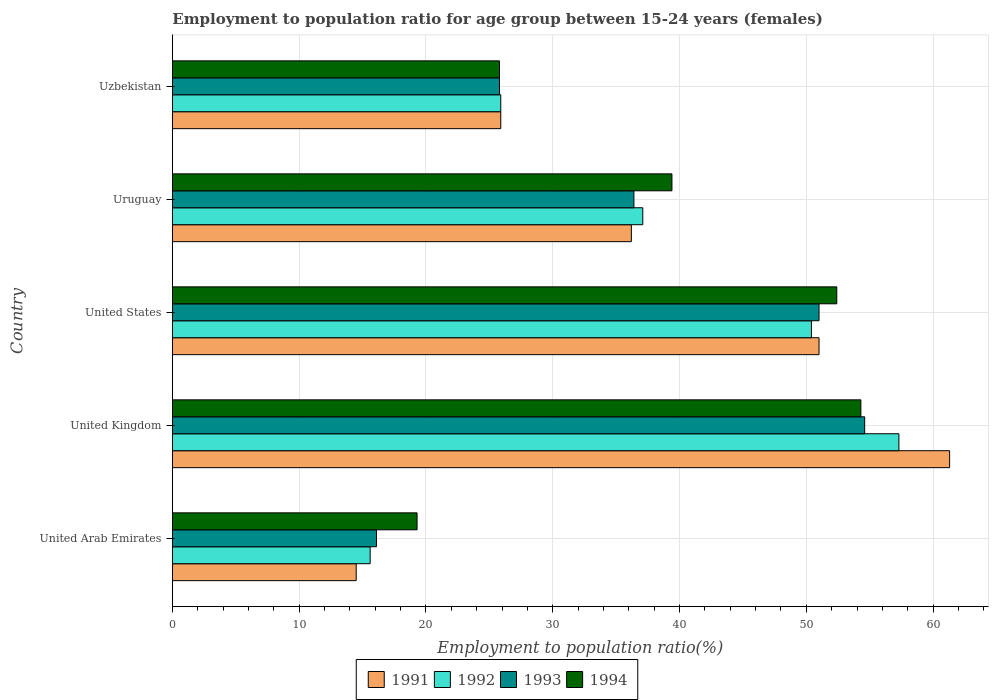How many groups of bars are there?
Ensure brevity in your answer.  5. How many bars are there on the 5th tick from the bottom?
Your response must be concise. 4. What is the label of the 5th group of bars from the top?
Make the answer very short. United Arab Emirates. What is the employment to population ratio in 1992 in United Kingdom?
Ensure brevity in your answer.  57.3. Across all countries, what is the maximum employment to population ratio in 1991?
Your answer should be compact. 61.3. Across all countries, what is the minimum employment to population ratio in 1993?
Keep it short and to the point. 16.1. In which country was the employment to population ratio in 1992 minimum?
Offer a terse response. United Arab Emirates. What is the total employment to population ratio in 1992 in the graph?
Your answer should be very brief. 186.3. What is the difference between the employment to population ratio in 1991 in Uruguay and that in Uzbekistan?
Give a very brief answer. 10.3. What is the difference between the employment to population ratio in 1992 in United Kingdom and the employment to population ratio in 1994 in United Arab Emirates?
Your answer should be very brief. 38. What is the average employment to population ratio in 1992 per country?
Your answer should be compact. 37.26. What is the difference between the employment to population ratio in 1991 and employment to population ratio in 1992 in Uruguay?
Provide a succinct answer. -0.9. What is the ratio of the employment to population ratio in 1993 in United Arab Emirates to that in United States?
Provide a succinct answer. 0.32. Is the employment to population ratio in 1994 in United Arab Emirates less than that in Uruguay?
Give a very brief answer. Yes. Is the difference between the employment to population ratio in 1991 in United Arab Emirates and Uzbekistan greater than the difference between the employment to population ratio in 1992 in United Arab Emirates and Uzbekistan?
Your answer should be compact. No. What is the difference between the highest and the second highest employment to population ratio in 1992?
Give a very brief answer. 6.9. What is the difference between the highest and the lowest employment to population ratio in 1992?
Offer a terse response. 41.7. Is it the case that in every country, the sum of the employment to population ratio in 1993 and employment to population ratio in 1992 is greater than the sum of employment to population ratio in 1994 and employment to population ratio in 1991?
Offer a terse response. No. Are all the bars in the graph horizontal?
Make the answer very short. Yes. How many countries are there in the graph?
Offer a very short reply. 5. What is the difference between two consecutive major ticks on the X-axis?
Your response must be concise. 10. Are the values on the major ticks of X-axis written in scientific E-notation?
Provide a succinct answer. No. Does the graph contain any zero values?
Your response must be concise. No. Where does the legend appear in the graph?
Your answer should be compact. Bottom center. How many legend labels are there?
Make the answer very short. 4. What is the title of the graph?
Your answer should be compact. Employment to population ratio for age group between 15-24 years (females). Does "1990" appear as one of the legend labels in the graph?
Give a very brief answer. No. What is the label or title of the X-axis?
Provide a succinct answer. Employment to population ratio(%). What is the label or title of the Y-axis?
Ensure brevity in your answer.  Country. What is the Employment to population ratio(%) of 1991 in United Arab Emirates?
Your response must be concise. 14.5. What is the Employment to population ratio(%) in 1992 in United Arab Emirates?
Offer a very short reply. 15.6. What is the Employment to population ratio(%) of 1993 in United Arab Emirates?
Make the answer very short. 16.1. What is the Employment to population ratio(%) in 1994 in United Arab Emirates?
Your answer should be compact. 19.3. What is the Employment to population ratio(%) in 1991 in United Kingdom?
Keep it short and to the point. 61.3. What is the Employment to population ratio(%) in 1992 in United Kingdom?
Your answer should be compact. 57.3. What is the Employment to population ratio(%) in 1993 in United Kingdom?
Offer a terse response. 54.6. What is the Employment to population ratio(%) in 1994 in United Kingdom?
Provide a short and direct response. 54.3. What is the Employment to population ratio(%) of 1991 in United States?
Your answer should be compact. 51. What is the Employment to population ratio(%) in 1992 in United States?
Offer a terse response. 50.4. What is the Employment to population ratio(%) in 1993 in United States?
Make the answer very short. 51. What is the Employment to population ratio(%) in 1994 in United States?
Offer a very short reply. 52.4. What is the Employment to population ratio(%) in 1991 in Uruguay?
Provide a succinct answer. 36.2. What is the Employment to population ratio(%) of 1992 in Uruguay?
Ensure brevity in your answer.  37.1. What is the Employment to population ratio(%) in 1993 in Uruguay?
Provide a succinct answer. 36.4. What is the Employment to population ratio(%) of 1994 in Uruguay?
Make the answer very short. 39.4. What is the Employment to population ratio(%) of 1991 in Uzbekistan?
Make the answer very short. 25.9. What is the Employment to population ratio(%) in 1992 in Uzbekistan?
Make the answer very short. 25.9. What is the Employment to population ratio(%) of 1993 in Uzbekistan?
Your response must be concise. 25.8. What is the Employment to population ratio(%) of 1994 in Uzbekistan?
Give a very brief answer. 25.8. Across all countries, what is the maximum Employment to population ratio(%) of 1991?
Offer a very short reply. 61.3. Across all countries, what is the maximum Employment to population ratio(%) of 1992?
Your response must be concise. 57.3. Across all countries, what is the maximum Employment to population ratio(%) of 1993?
Your answer should be compact. 54.6. Across all countries, what is the maximum Employment to population ratio(%) in 1994?
Ensure brevity in your answer.  54.3. Across all countries, what is the minimum Employment to population ratio(%) in 1991?
Ensure brevity in your answer.  14.5. Across all countries, what is the minimum Employment to population ratio(%) in 1992?
Provide a short and direct response. 15.6. Across all countries, what is the minimum Employment to population ratio(%) in 1993?
Provide a short and direct response. 16.1. Across all countries, what is the minimum Employment to population ratio(%) in 1994?
Make the answer very short. 19.3. What is the total Employment to population ratio(%) in 1991 in the graph?
Provide a succinct answer. 188.9. What is the total Employment to population ratio(%) of 1992 in the graph?
Offer a very short reply. 186.3. What is the total Employment to population ratio(%) in 1993 in the graph?
Provide a succinct answer. 183.9. What is the total Employment to population ratio(%) in 1994 in the graph?
Provide a succinct answer. 191.2. What is the difference between the Employment to population ratio(%) in 1991 in United Arab Emirates and that in United Kingdom?
Give a very brief answer. -46.8. What is the difference between the Employment to population ratio(%) in 1992 in United Arab Emirates and that in United Kingdom?
Give a very brief answer. -41.7. What is the difference between the Employment to population ratio(%) of 1993 in United Arab Emirates and that in United Kingdom?
Keep it short and to the point. -38.5. What is the difference between the Employment to population ratio(%) of 1994 in United Arab Emirates and that in United Kingdom?
Offer a very short reply. -35. What is the difference between the Employment to population ratio(%) in 1991 in United Arab Emirates and that in United States?
Ensure brevity in your answer.  -36.5. What is the difference between the Employment to population ratio(%) in 1992 in United Arab Emirates and that in United States?
Make the answer very short. -34.8. What is the difference between the Employment to population ratio(%) of 1993 in United Arab Emirates and that in United States?
Keep it short and to the point. -34.9. What is the difference between the Employment to population ratio(%) in 1994 in United Arab Emirates and that in United States?
Provide a succinct answer. -33.1. What is the difference between the Employment to population ratio(%) of 1991 in United Arab Emirates and that in Uruguay?
Keep it short and to the point. -21.7. What is the difference between the Employment to population ratio(%) of 1992 in United Arab Emirates and that in Uruguay?
Make the answer very short. -21.5. What is the difference between the Employment to population ratio(%) in 1993 in United Arab Emirates and that in Uruguay?
Offer a very short reply. -20.3. What is the difference between the Employment to population ratio(%) in 1994 in United Arab Emirates and that in Uruguay?
Ensure brevity in your answer.  -20.1. What is the difference between the Employment to population ratio(%) of 1992 in United Arab Emirates and that in Uzbekistan?
Offer a very short reply. -10.3. What is the difference between the Employment to population ratio(%) in 1993 in United Arab Emirates and that in Uzbekistan?
Offer a very short reply. -9.7. What is the difference between the Employment to population ratio(%) in 1991 in United Kingdom and that in United States?
Provide a short and direct response. 10.3. What is the difference between the Employment to population ratio(%) in 1992 in United Kingdom and that in United States?
Provide a succinct answer. 6.9. What is the difference between the Employment to population ratio(%) of 1993 in United Kingdom and that in United States?
Provide a short and direct response. 3.6. What is the difference between the Employment to population ratio(%) of 1994 in United Kingdom and that in United States?
Offer a very short reply. 1.9. What is the difference between the Employment to population ratio(%) in 1991 in United Kingdom and that in Uruguay?
Offer a very short reply. 25.1. What is the difference between the Employment to population ratio(%) of 1992 in United Kingdom and that in Uruguay?
Your answer should be compact. 20.2. What is the difference between the Employment to population ratio(%) in 1994 in United Kingdom and that in Uruguay?
Keep it short and to the point. 14.9. What is the difference between the Employment to population ratio(%) in 1991 in United Kingdom and that in Uzbekistan?
Provide a succinct answer. 35.4. What is the difference between the Employment to population ratio(%) of 1992 in United Kingdom and that in Uzbekistan?
Provide a short and direct response. 31.4. What is the difference between the Employment to population ratio(%) in 1993 in United Kingdom and that in Uzbekistan?
Make the answer very short. 28.8. What is the difference between the Employment to population ratio(%) in 1992 in United States and that in Uruguay?
Offer a very short reply. 13.3. What is the difference between the Employment to population ratio(%) in 1994 in United States and that in Uruguay?
Offer a very short reply. 13. What is the difference between the Employment to population ratio(%) of 1991 in United States and that in Uzbekistan?
Offer a terse response. 25.1. What is the difference between the Employment to population ratio(%) of 1992 in United States and that in Uzbekistan?
Give a very brief answer. 24.5. What is the difference between the Employment to population ratio(%) of 1993 in United States and that in Uzbekistan?
Your answer should be very brief. 25.2. What is the difference between the Employment to population ratio(%) in 1994 in United States and that in Uzbekistan?
Your answer should be very brief. 26.6. What is the difference between the Employment to population ratio(%) in 1991 in Uruguay and that in Uzbekistan?
Offer a terse response. 10.3. What is the difference between the Employment to population ratio(%) of 1993 in Uruguay and that in Uzbekistan?
Give a very brief answer. 10.6. What is the difference between the Employment to population ratio(%) in 1994 in Uruguay and that in Uzbekistan?
Your response must be concise. 13.6. What is the difference between the Employment to population ratio(%) of 1991 in United Arab Emirates and the Employment to population ratio(%) of 1992 in United Kingdom?
Give a very brief answer. -42.8. What is the difference between the Employment to population ratio(%) in 1991 in United Arab Emirates and the Employment to population ratio(%) in 1993 in United Kingdom?
Your answer should be very brief. -40.1. What is the difference between the Employment to population ratio(%) of 1991 in United Arab Emirates and the Employment to population ratio(%) of 1994 in United Kingdom?
Provide a succinct answer. -39.8. What is the difference between the Employment to population ratio(%) of 1992 in United Arab Emirates and the Employment to population ratio(%) of 1993 in United Kingdom?
Keep it short and to the point. -39. What is the difference between the Employment to population ratio(%) of 1992 in United Arab Emirates and the Employment to population ratio(%) of 1994 in United Kingdom?
Make the answer very short. -38.7. What is the difference between the Employment to population ratio(%) of 1993 in United Arab Emirates and the Employment to population ratio(%) of 1994 in United Kingdom?
Ensure brevity in your answer.  -38.2. What is the difference between the Employment to population ratio(%) of 1991 in United Arab Emirates and the Employment to population ratio(%) of 1992 in United States?
Provide a short and direct response. -35.9. What is the difference between the Employment to population ratio(%) in 1991 in United Arab Emirates and the Employment to population ratio(%) in 1993 in United States?
Your answer should be very brief. -36.5. What is the difference between the Employment to population ratio(%) of 1991 in United Arab Emirates and the Employment to population ratio(%) of 1994 in United States?
Offer a very short reply. -37.9. What is the difference between the Employment to population ratio(%) of 1992 in United Arab Emirates and the Employment to population ratio(%) of 1993 in United States?
Your answer should be compact. -35.4. What is the difference between the Employment to population ratio(%) of 1992 in United Arab Emirates and the Employment to population ratio(%) of 1994 in United States?
Make the answer very short. -36.8. What is the difference between the Employment to population ratio(%) of 1993 in United Arab Emirates and the Employment to population ratio(%) of 1994 in United States?
Ensure brevity in your answer.  -36.3. What is the difference between the Employment to population ratio(%) of 1991 in United Arab Emirates and the Employment to population ratio(%) of 1992 in Uruguay?
Offer a terse response. -22.6. What is the difference between the Employment to population ratio(%) in 1991 in United Arab Emirates and the Employment to population ratio(%) in 1993 in Uruguay?
Your response must be concise. -21.9. What is the difference between the Employment to population ratio(%) in 1991 in United Arab Emirates and the Employment to population ratio(%) in 1994 in Uruguay?
Provide a short and direct response. -24.9. What is the difference between the Employment to population ratio(%) in 1992 in United Arab Emirates and the Employment to population ratio(%) in 1993 in Uruguay?
Keep it short and to the point. -20.8. What is the difference between the Employment to population ratio(%) of 1992 in United Arab Emirates and the Employment to population ratio(%) of 1994 in Uruguay?
Keep it short and to the point. -23.8. What is the difference between the Employment to population ratio(%) in 1993 in United Arab Emirates and the Employment to population ratio(%) in 1994 in Uruguay?
Ensure brevity in your answer.  -23.3. What is the difference between the Employment to population ratio(%) in 1991 in United Arab Emirates and the Employment to population ratio(%) in 1994 in Uzbekistan?
Make the answer very short. -11.3. What is the difference between the Employment to population ratio(%) in 1991 in United Kingdom and the Employment to population ratio(%) in 1992 in United States?
Give a very brief answer. 10.9. What is the difference between the Employment to population ratio(%) of 1992 in United Kingdom and the Employment to population ratio(%) of 1993 in United States?
Provide a succinct answer. 6.3. What is the difference between the Employment to population ratio(%) of 1992 in United Kingdom and the Employment to population ratio(%) of 1994 in United States?
Provide a succinct answer. 4.9. What is the difference between the Employment to population ratio(%) in 1991 in United Kingdom and the Employment to population ratio(%) in 1992 in Uruguay?
Provide a short and direct response. 24.2. What is the difference between the Employment to population ratio(%) in 1991 in United Kingdom and the Employment to population ratio(%) in 1993 in Uruguay?
Your response must be concise. 24.9. What is the difference between the Employment to population ratio(%) of 1991 in United Kingdom and the Employment to population ratio(%) of 1994 in Uruguay?
Your answer should be very brief. 21.9. What is the difference between the Employment to population ratio(%) in 1992 in United Kingdom and the Employment to population ratio(%) in 1993 in Uruguay?
Provide a succinct answer. 20.9. What is the difference between the Employment to population ratio(%) of 1991 in United Kingdom and the Employment to population ratio(%) of 1992 in Uzbekistan?
Offer a terse response. 35.4. What is the difference between the Employment to population ratio(%) of 1991 in United Kingdom and the Employment to population ratio(%) of 1993 in Uzbekistan?
Your answer should be very brief. 35.5. What is the difference between the Employment to population ratio(%) in 1991 in United Kingdom and the Employment to population ratio(%) in 1994 in Uzbekistan?
Your response must be concise. 35.5. What is the difference between the Employment to population ratio(%) of 1992 in United Kingdom and the Employment to population ratio(%) of 1993 in Uzbekistan?
Give a very brief answer. 31.5. What is the difference between the Employment to population ratio(%) in 1992 in United Kingdom and the Employment to population ratio(%) in 1994 in Uzbekistan?
Your answer should be compact. 31.5. What is the difference between the Employment to population ratio(%) in 1993 in United Kingdom and the Employment to population ratio(%) in 1994 in Uzbekistan?
Give a very brief answer. 28.8. What is the difference between the Employment to population ratio(%) in 1991 in United States and the Employment to population ratio(%) in 1992 in Uruguay?
Ensure brevity in your answer.  13.9. What is the difference between the Employment to population ratio(%) in 1991 in United States and the Employment to population ratio(%) in 1993 in Uruguay?
Offer a terse response. 14.6. What is the difference between the Employment to population ratio(%) in 1991 in United States and the Employment to population ratio(%) in 1994 in Uruguay?
Your response must be concise. 11.6. What is the difference between the Employment to population ratio(%) of 1992 in United States and the Employment to population ratio(%) of 1994 in Uruguay?
Offer a terse response. 11. What is the difference between the Employment to population ratio(%) in 1993 in United States and the Employment to population ratio(%) in 1994 in Uruguay?
Give a very brief answer. 11.6. What is the difference between the Employment to population ratio(%) in 1991 in United States and the Employment to population ratio(%) in 1992 in Uzbekistan?
Ensure brevity in your answer.  25.1. What is the difference between the Employment to population ratio(%) in 1991 in United States and the Employment to population ratio(%) in 1993 in Uzbekistan?
Ensure brevity in your answer.  25.2. What is the difference between the Employment to population ratio(%) of 1991 in United States and the Employment to population ratio(%) of 1994 in Uzbekistan?
Make the answer very short. 25.2. What is the difference between the Employment to population ratio(%) of 1992 in United States and the Employment to population ratio(%) of 1993 in Uzbekistan?
Your answer should be very brief. 24.6. What is the difference between the Employment to population ratio(%) of 1992 in United States and the Employment to population ratio(%) of 1994 in Uzbekistan?
Your answer should be compact. 24.6. What is the difference between the Employment to population ratio(%) of 1993 in United States and the Employment to population ratio(%) of 1994 in Uzbekistan?
Make the answer very short. 25.2. What is the difference between the Employment to population ratio(%) of 1991 in Uruguay and the Employment to population ratio(%) of 1993 in Uzbekistan?
Your answer should be very brief. 10.4. What is the difference between the Employment to population ratio(%) in 1992 in Uruguay and the Employment to population ratio(%) in 1993 in Uzbekistan?
Offer a terse response. 11.3. What is the difference between the Employment to population ratio(%) of 1992 in Uruguay and the Employment to population ratio(%) of 1994 in Uzbekistan?
Your answer should be compact. 11.3. What is the average Employment to population ratio(%) of 1991 per country?
Your answer should be very brief. 37.78. What is the average Employment to population ratio(%) of 1992 per country?
Provide a short and direct response. 37.26. What is the average Employment to population ratio(%) in 1993 per country?
Offer a terse response. 36.78. What is the average Employment to population ratio(%) in 1994 per country?
Give a very brief answer. 38.24. What is the difference between the Employment to population ratio(%) of 1991 and Employment to population ratio(%) of 1992 in United Arab Emirates?
Ensure brevity in your answer.  -1.1. What is the difference between the Employment to population ratio(%) of 1991 and Employment to population ratio(%) of 1994 in United Arab Emirates?
Give a very brief answer. -4.8. What is the difference between the Employment to population ratio(%) in 1992 and Employment to population ratio(%) in 1993 in United Arab Emirates?
Offer a very short reply. -0.5. What is the difference between the Employment to population ratio(%) of 1992 and Employment to population ratio(%) of 1994 in United Arab Emirates?
Your answer should be compact. -3.7. What is the difference between the Employment to population ratio(%) in 1993 and Employment to population ratio(%) in 1994 in United Arab Emirates?
Give a very brief answer. -3.2. What is the difference between the Employment to population ratio(%) of 1991 and Employment to population ratio(%) of 1994 in United Kingdom?
Your answer should be compact. 7. What is the difference between the Employment to population ratio(%) in 1992 and Employment to population ratio(%) in 1993 in United Kingdom?
Offer a very short reply. 2.7. What is the difference between the Employment to population ratio(%) in 1991 and Employment to population ratio(%) in 1993 in United States?
Give a very brief answer. 0. What is the difference between the Employment to population ratio(%) in 1993 and Employment to population ratio(%) in 1994 in United States?
Provide a short and direct response. -1.4. What is the difference between the Employment to population ratio(%) in 1991 and Employment to population ratio(%) in 1994 in Uruguay?
Provide a succinct answer. -3.2. What is the difference between the Employment to population ratio(%) of 1991 and Employment to population ratio(%) of 1992 in Uzbekistan?
Offer a terse response. 0. What is the difference between the Employment to population ratio(%) of 1991 and Employment to population ratio(%) of 1994 in Uzbekistan?
Ensure brevity in your answer.  0.1. What is the difference between the Employment to population ratio(%) of 1992 and Employment to population ratio(%) of 1994 in Uzbekistan?
Offer a very short reply. 0.1. What is the difference between the Employment to population ratio(%) in 1993 and Employment to population ratio(%) in 1994 in Uzbekistan?
Offer a very short reply. 0. What is the ratio of the Employment to population ratio(%) of 1991 in United Arab Emirates to that in United Kingdom?
Give a very brief answer. 0.24. What is the ratio of the Employment to population ratio(%) in 1992 in United Arab Emirates to that in United Kingdom?
Your answer should be very brief. 0.27. What is the ratio of the Employment to population ratio(%) in 1993 in United Arab Emirates to that in United Kingdom?
Give a very brief answer. 0.29. What is the ratio of the Employment to population ratio(%) in 1994 in United Arab Emirates to that in United Kingdom?
Ensure brevity in your answer.  0.36. What is the ratio of the Employment to population ratio(%) of 1991 in United Arab Emirates to that in United States?
Your response must be concise. 0.28. What is the ratio of the Employment to population ratio(%) in 1992 in United Arab Emirates to that in United States?
Make the answer very short. 0.31. What is the ratio of the Employment to population ratio(%) in 1993 in United Arab Emirates to that in United States?
Give a very brief answer. 0.32. What is the ratio of the Employment to population ratio(%) of 1994 in United Arab Emirates to that in United States?
Offer a very short reply. 0.37. What is the ratio of the Employment to population ratio(%) of 1991 in United Arab Emirates to that in Uruguay?
Ensure brevity in your answer.  0.4. What is the ratio of the Employment to population ratio(%) in 1992 in United Arab Emirates to that in Uruguay?
Your answer should be compact. 0.42. What is the ratio of the Employment to population ratio(%) in 1993 in United Arab Emirates to that in Uruguay?
Keep it short and to the point. 0.44. What is the ratio of the Employment to population ratio(%) in 1994 in United Arab Emirates to that in Uruguay?
Provide a short and direct response. 0.49. What is the ratio of the Employment to population ratio(%) in 1991 in United Arab Emirates to that in Uzbekistan?
Ensure brevity in your answer.  0.56. What is the ratio of the Employment to population ratio(%) of 1992 in United Arab Emirates to that in Uzbekistan?
Your response must be concise. 0.6. What is the ratio of the Employment to population ratio(%) in 1993 in United Arab Emirates to that in Uzbekistan?
Provide a succinct answer. 0.62. What is the ratio of the Employment to population ratio(%) of 1994 in United Arab Emirates to that in Uzbekistan?
Make the answer very short. 0.75. What is the ratio of the Employment to population ratio(%) of 1991 in United Kingdom to that in United States?
Make the answer very short. 1.2. What is the ratio of the Employment to population ratio(%) of 1992 in United Kingdom to that in United States?
Provide a succinct answer. 1.14. What is the ratio of the Employment to population ratio(%) of 1993 in United Kingdom to that in United States?
Keep it short and to the point. 1.07. What is the ratio of the Employment to population ratio(%) in 1994 in United Kingdom to that in United States?
Provide a succinct answer. 1.04. What is the ratio of the Employment to population ratio(%) in 1991 in United Kingdom to that in Uruguay?
Give a very brief answer. 1.69. What is the ratio of the Employment to population ratio(%) in 1992 in United Kingdom to that in Uruguay?
Your answer should be very brief. 1.54. What is the ratio of the Employment to population ratio(%) of 1993 in United Kingdom to that in Uruguay?
Your response must be concise. 1.5. What is the ratio of the Employment to population ratio(%) in 1994 in United Kingdom to that in Uruguay?
Your answer should be compact. 1.38. What is the ratio of the Employment to population ratio(%) of 1991 in United Kingdom to that in Uzbekistan?
Your answer should be very brief. 2.37. What is the ratio of the Employment to population ratio(%) in 1992 in United Kingdom to that in Uzbekistan?
Offer a terse response. 2.21. What is the ratio of the Employment to population ratio(%) of 1993 in United Kingdom to that in Uzbekistan?
Your answer should be compact. 2.12. What is the ratio of the Employment to population ratio(%) in 1994 in United Kingdom to that in Uzbekistan?
Make the answer very short. 2.1. What is the ratio of the Employment to population ratio(%) of 1991 in United States to that in Uruguay?
Offer a terse response. 1.41. What is the ratio of the Employment to population ratio(%) of 1992 in United States to that in Uruguay?
Ensure brevity in your answer.  1.36. What is the ratio of the Employment to population ratio(%) of 1993 in United States to that in Uruguay?
Offer a terse response. 1.4. What is the ratio of the Employment to population ratio(%) in 1994 in United States to that in Uruguay?
Offer a very short reply. 1.33. What is the ratio of the Employment to population ratio(%) in 1991 in United States to that in Uzbekistan?
Your response must be concise. 1.97. What is the ratio of the Employment to population ratio(%) of 1992 in United States to that in Uzbekistan?
Ensure brevity in your answer.  1.95. What is the ratio of the Employment to population ratio(%) of 1993 in United States to that in Uzbekistan?
Keep it short and to the point. 1.98. What is the ratio of the Employment to population ratio(%) of 1994 in United States to that in Uzbekistan?
Your response must be concise. 2.03. What is the ratio of the Employment to population ratio(%) of 1991 in Uruguay to that in Uzbekistan?
Provide a short and direct response. 1.4. What is the ratio of the Employment to population ratio(%) of 1992 in Uruguay to that in Uzbekistan?
Your answer should be compact. 1.43. What is the ratio of the Employment to population ratio(%) of 1993 in Uruguay to that in Uzbekistan?
Give a very brief answer. 1.41. What is the ratio of the Employment to population ratio(%) of 1994 in Uruguay to that in Uzbekistan?
Your response must be concise. 1.53. What is the difference between the highest and the lowest Employment to population ratio(%) in 1991?
Your response must be concise. 46.8. What is the difference between the highest and the lowest Employment to population ratio(%) in 1992?
Make the answer very short. 41.7. What is the difference between the highest and the lowest Employment to population ratio(%) in 1993?
Make the answer very short. 38.5. 